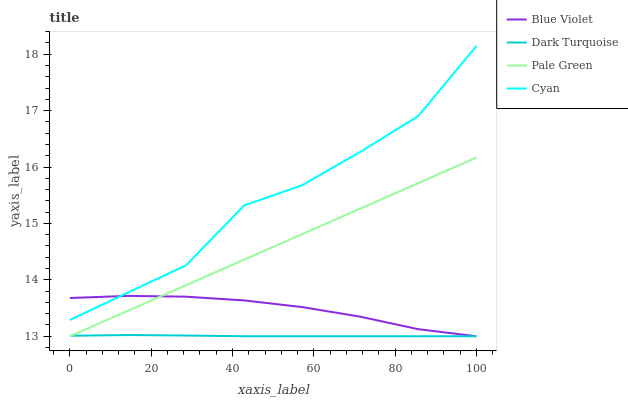Does Dark Turquoise have the minimum area under the curve?
Answer yes or no. Yes. Does Cyan have the maximum area under the curve?
Answer yes or no. Yes. Does Pale Green have the minimum area under the curve?
Answer yes or no. No. Does Pale Green have the maximum area under the curve?
Answer yes or no. No. Is Pale Green the smoothest?
Answer yes or no. Yes. Is Cyan the roughest?
Answer yes or no. Yes. Is Blue Violet the smoothest?
Answer yes or no. No. Is Blue Violet the roughest?
Answer yes or no. No. Does Dark Turquoise have the lowest value?
Answer yes or no. Yes. Does Cyan have the lowest value?
Answer yes or no. No. Does Cyan have the highest value?
Answer yes or no. Yes. Does Pale Green have the highest value?
Answer yes or no. No. Is Pale Green less than Cyan?
Answer yes or no. Yes. Is Cyan greater than Pale Green?
Answer yes or no. Yes. Does Pale Green intersect Dark Turquoise?
Answer yes or no. Yes. Is Pale Green less than Dark Turquoise?
Answer yes or no. No. Is Pale Green greater than Dark Turquoise?
Answer yes or no. No. Does Pale Green intersect Cyan?
Answer yes or no. No. 